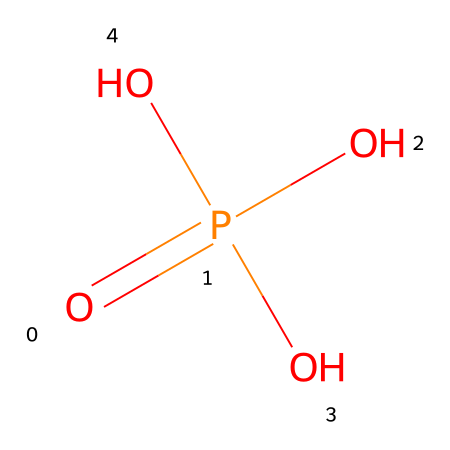How many oxygen atoms are in phosphoric acid? The SMILES representation shows "O" three times, which indicates the presence of three oxygen atoms. Counting these gives the total number of oxygen atoms in the molecule.
Answer: three What is the central atom in phosphoric acid? In the SMILES representation, "P" is located before the equal sign and indicates that phosphorus is the central atom of the molecule.
Answer: phosphorus How many hydrogen atoms are present in phosphoric acid? The SMILES structure indicates that there are three -OH (hydroxyl) groups, each contributing one hydrogen atom. Thus, there are three hydrogen atoms in total in the molecule.
Answer: three Which type of compound is phosphoric acid? Phosphoric acid contains phosphorus and has acidic properties due to the availability of protons from the hydroxyl groups. It fits the classification of an acid based on its structure and properties.
Answer: acid What is the total number of bonds connected to the phosphorus atom? Analyzing the SMILES structure, phosphorus is bonded to four oxygens: one with a double bond and three with single bonds. Therefore, there are a total of four bonds connected to phosphorus.
Answer: four What functional groups are present in phosphoric acid? The presence of three hydroxyl (-OH) groups in the structure indicates that phosphoric acid contains hydroxyl functional groups, which are characteristic of alcohols and acids.
Answer: hydroxyl groups What type of oxygen bond is present between phosphorus and one of the oxygen atoms? The representation shows one "O" connected to "P" with a double bond, indicating a double bond between phosphorus and that specific oxygen atom.
Answer: double bond 